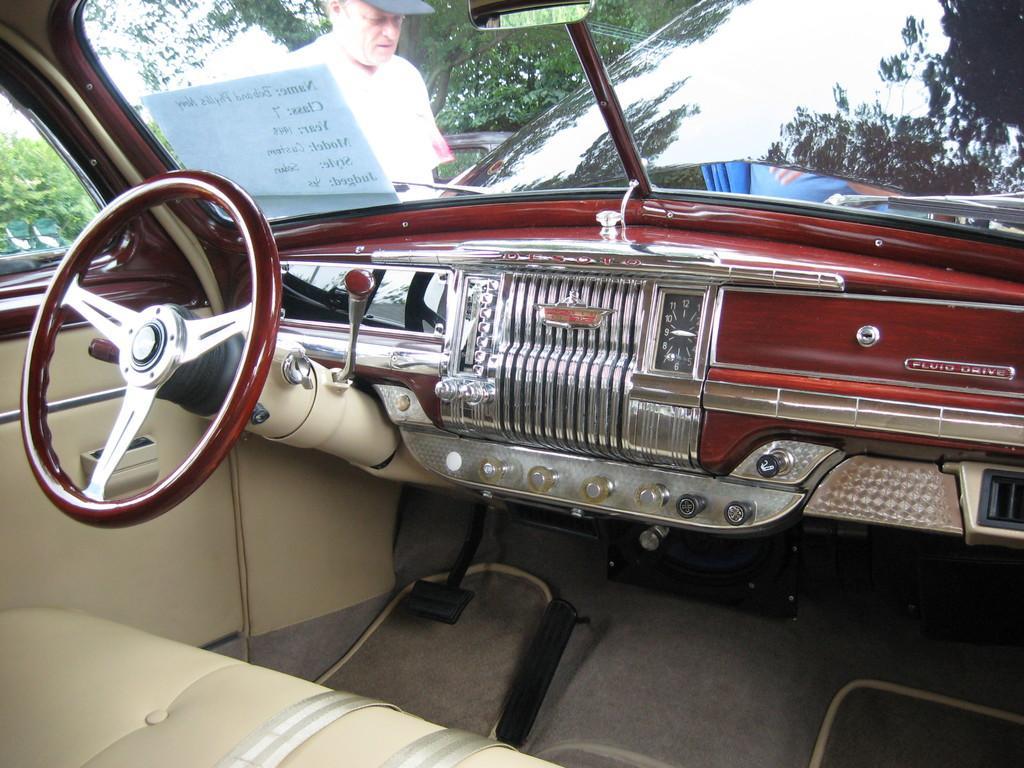Please provide a concise description of this image. In this picture we can see an inside view of a car, on the left side there is a steering, we can see glass in the middle, from the glass we can see a man and a tree, there is a paper pasted on the glass. 